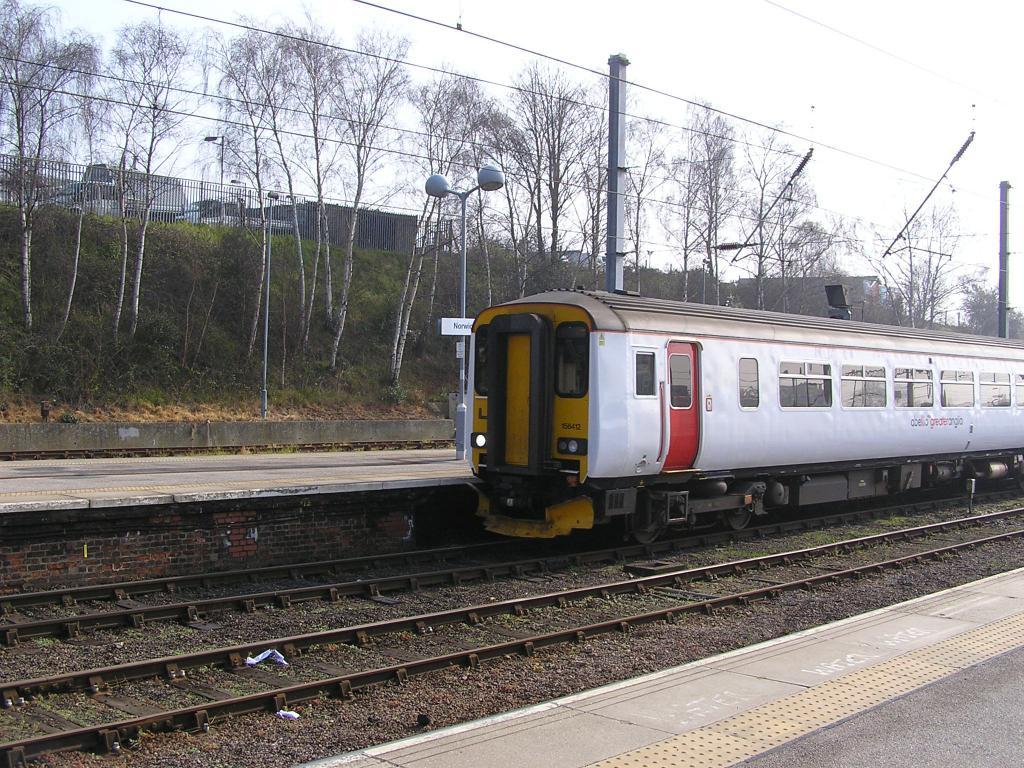What is the main subject in the center of the image? There is a train in the center of the image. What is the train situated on? There is a train track in the image. What can be seen in the background of the image? There are trees in the background of the image. What else is present in the image besides the train and trees? There are electric poles and wires, as well as a fencing. What type of nail is being used to hold the train together in the image? There is no nail present in the image, and the train does not appear to be held together by any visible nails. 